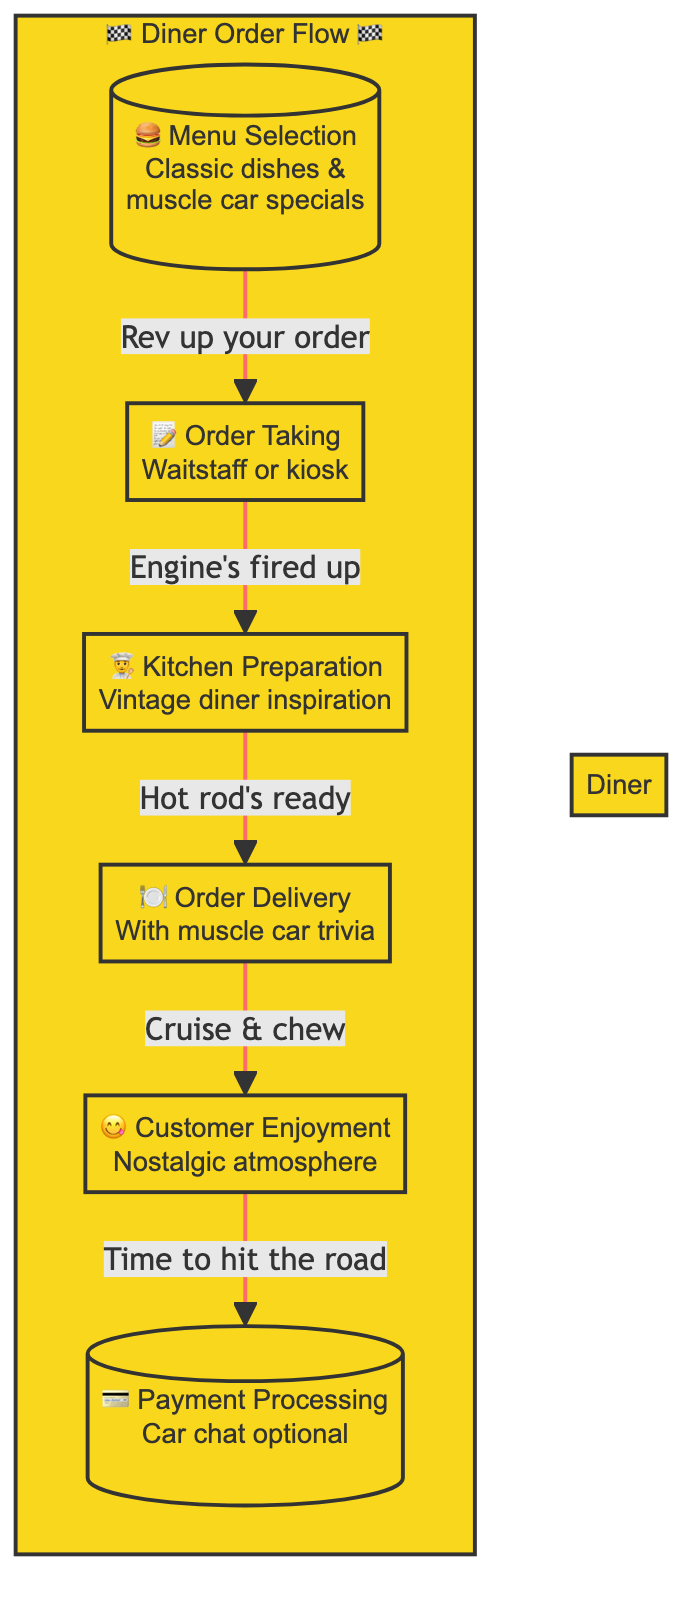What is the first step in the customer order process? The first step is "Menu Selection." It is the beginning of the flow as depicted at the top of the flowchart.
Answer: Menu Selection How many total steps are there in the flowchart? There are six steps, including Menu Selection, Order Taking, Kitchen Preparation, Order Delivery, Customer Enjoyment, and Payment Processing.
Answer: Six Which step comes after Kitchen Preparation? The step that follows Kitchen Preparation is Order Delivery, as indicated by the arrow leading from one to the other in the diagram.
Answer: Order Delivery What does the customer discuss during Payment Processing? During Payment Processing, customers potentially discuss their favorite muscle cars with the staff, as noted in the description next to that step.
Answer: Favorite muscle cars What is the theme of the Customer Enjoyment step? The theme of Customer Enjoyment is nostalgia, where customers enjoy their meal while reminiscing about classic cars and the diner atmosphere.
Answer: Nostalgia What action connects Order Taking and Kitchen Preparation? The action that connects Order Taking to Kitchen Preparation is "Engine's fired up," indicating the transition between these two steps.
Answer: Engine's fired up What unique feature is highlighted during Order Delivery? The unique feature highlighted during Order Delivery is sharing fun facts about muscle cars, enhancing the diner experience.
Answer: Muscle car trivia In which step do customers enjoy their meal? Customers enjoy their meal in the "Customer Enjoyment" step, where the atmosphere encourages reminiscence about classic cars.
Answer: Customer Enjoyment What is emphasized in the Menu Selection node? The emphasis in the Menu Selection node is on classic dishes and muscle car-themed specials, showcasing the diner’s unique offerings.
Answer: Muscle car specials 